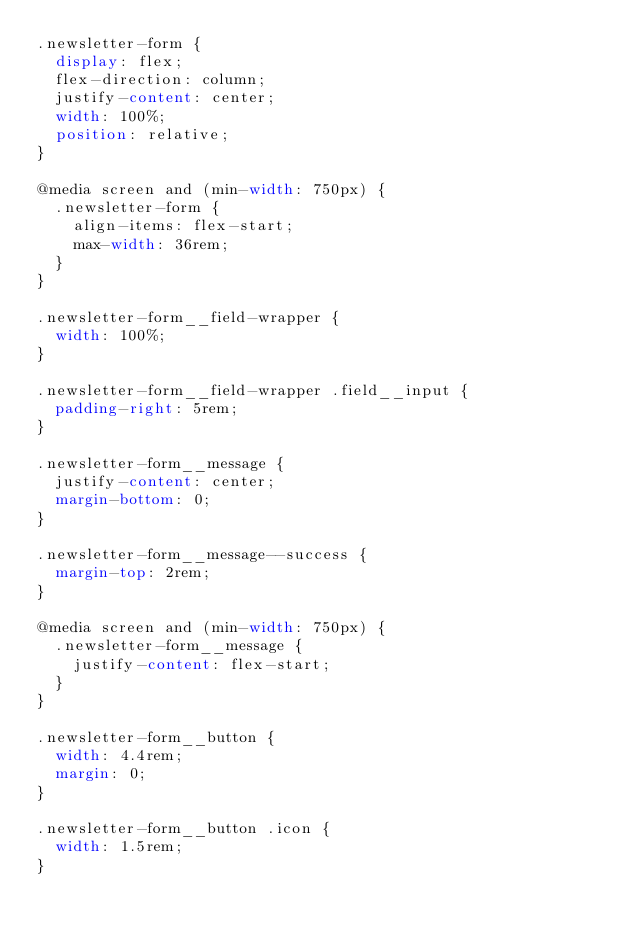Convert code to text. <code><loc_0><loc_0><loc_500><loc_500><_CSS_>.newsletter-form {
  display: flex;
  flex-direction: column;
  justify-content: center;
  width: 100%;
  position: relative;
}

@media screen and (min-width: 750px) {
  .newsletter-form {
    align-items: flex-start;
    max-width: 36rem;
  }
}

.newsletter-form__field-wrapper {
  width: 100%;
}

.newsletter-form__field-wrapper .field__input {
  padding-right: 5rem;
}

.newsletter-form__message {
  justify-content: center;
  margin-bottom: 0;
}

.newsletter-form__message--success {
  margin-top: 2rem;
}

@media screen and (min-width: 750px) {
  .newsletter-form__message {
    justify-content: flex-start;
  }
}

.newsletter-form__button {
  width: 4.4rem;
  margin: 0;
}

.newsletter-form__button .icon {
  width: 1.5rem;
}</code> 